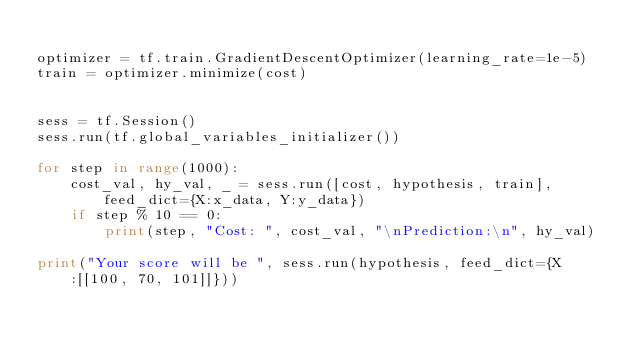<code> <loc_0><loc_0><loc_500><loc_500><_Python_>
optimizer = tf.train.GradientDescentOptimizer(learning_rate=1e-5)
train = optimizer.minimize(cost)


sess = tf.Session()
sess.run(tf.global_variables_initializer())

for step in range(1000):
    cost_val, hy_val, _ = sess.run([cost, hypothesis, train], feed_dict={X:x_data, Y:y_data})
    if step % 10 == 0:
        print(step, "Cost: ", cost_val, "\nPrediction:\n", hy_val)

print("Your score will be ", sess.run(hypothesis, feed_dict={X:[[100, 70, 101]]}))</code> 